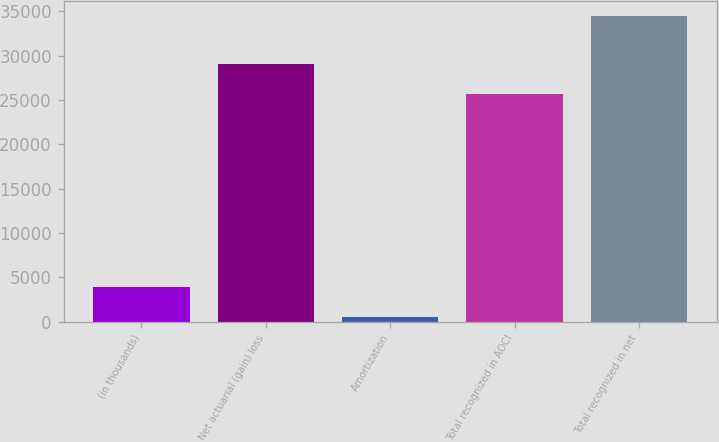Convert chart. <chart><loc_0><loc_0><loc_500><loc_500><bar_chart><fcel>(in thousands)<fcel>Net actuarial (gain) loss<fcel>Amortization<fcel>Total recognized in AOCI<fcel>Total recognized in net<nl><fcel>3924<fcel>29095<fcel>536<fcel>25707<fcel>34416<nl></chart> 